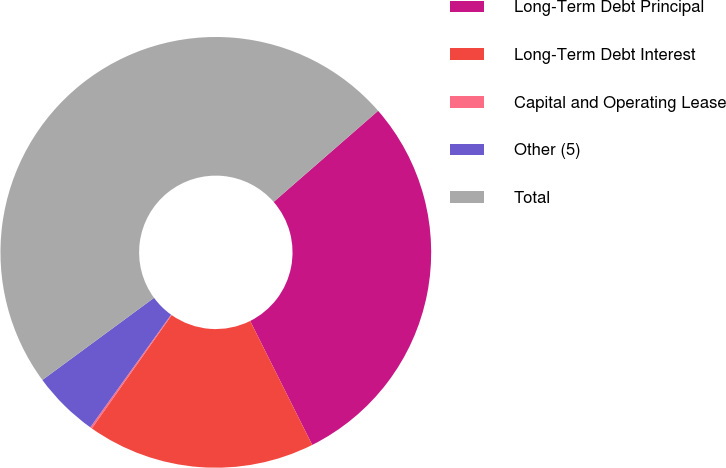<chart> <loc_0><loc_0><loc_500><loc_500><pie_chart><fcel>Long-Term Debt Principal<fcel>Long-Term Debt Interest<fcel>Capital and Operating Lease<fcel>Other (5)<fcel>Total<nl><fcel>29.03%<fcel>17.15%<fcel>0.14%<fcel>5.0%<fcel>48.68%<nl></chart> 